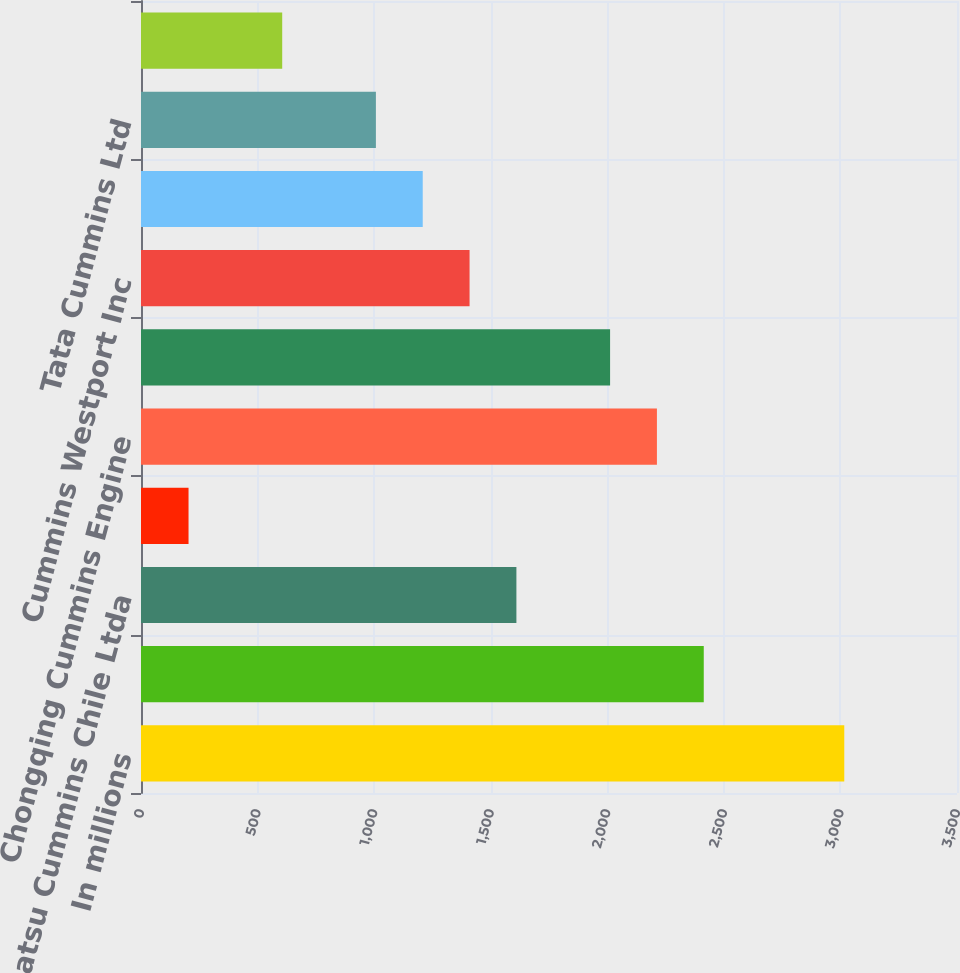<chart> <loc_0><loc_0><loc_500><loc_500><bar_chart><fcel>In millions<fcel>North American distributors<fcel>Komatsu Cummins Chile Ltda<fcel>All other distributors<fcel>Chongqing Cummins Engine<fcel>Dongfeng Cummins Engine<fcel>Cummins Westport Inc<fcel>Shanghai Fleetguard Filter Co<fcel>Tata Cummins Ltd<fcel>Valvoline Cummins Ltd<nl><fcel>3016.5<fcel>2413.8<fcel>1610.2<fcel>203.9<fcel>2212.9<fcel>2012<fcel>1409.3<fcel>1208.4<fcel>1007.5<fcel>605.7<nl></chart> 